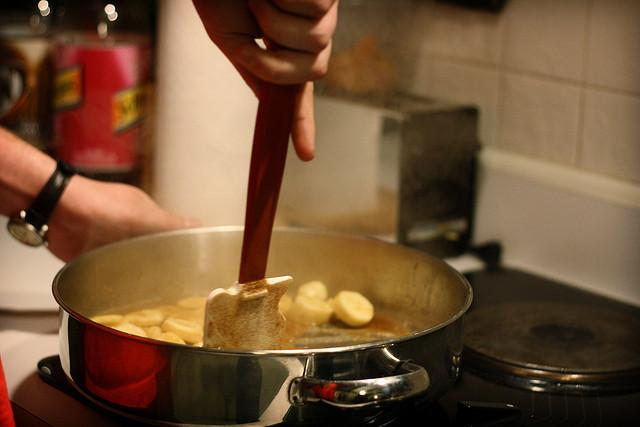What action is the person doing? cooking 